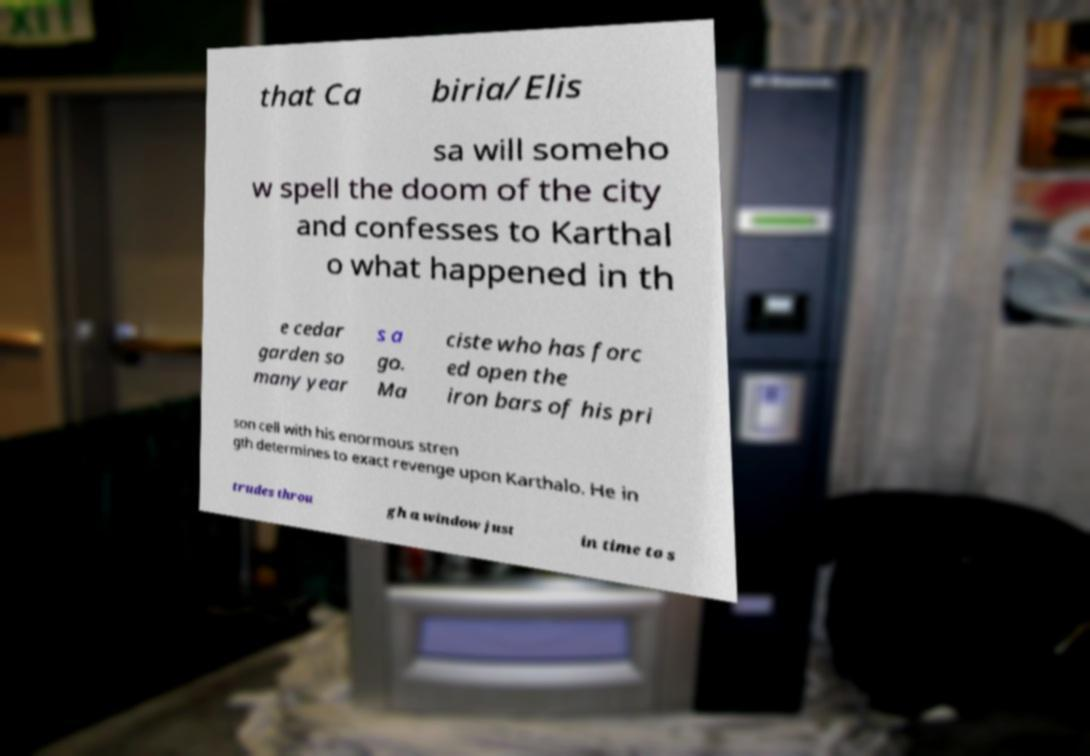For documentation purposes, I need the text within this image transcribed. Could you provide that? that Ca biria/Elis sa will someho w spell the doom of the city and confesses to Karthal o what happened in th e cedar garden so many year s a go. Ma ciste who has forc ed open the iron bars of his pri son cell with his enormous stren gth determines to exact revenge upon Karthalo. He in trudes throu gh a window just in time to s 